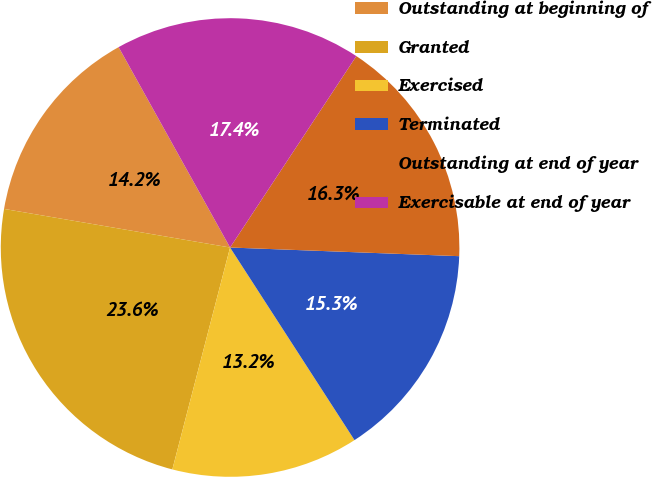Convert chart to OTSL. <chart><loc_0><loc_0><loc_500><loc_500><pie_chart><fcel>Outstanding at beginning of<fcel>Granted<fcel>Exercised<fcel>Terminated<fcel>Outstanding at end of year<fcel>Exercisable at end of year<nl><fcel>14.23%<fcel>23.64%<fcel>13.18%<fcel>15.27%<fcel>16.32%<fcel>17.36%<nl></chart> 